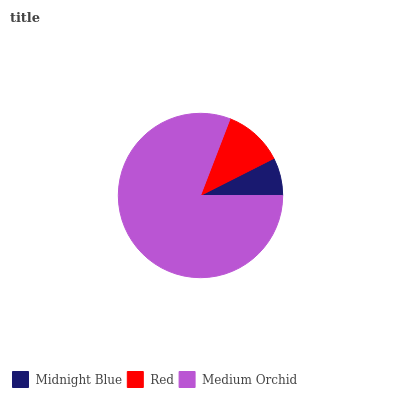Is Midnight Blue the minimum?
Answer yes or no. Yes. Is Medium Orchid the maximum?
Answer yes or no. Yes. Is Red the minimum?
Answer yes or no. No. Is Red the maximum?
Answer yes or no. No. Is Red greater than Midnight Blue?
Answer yes or no. Yes. Is Midnight Blue less than Red?
Answer yes or no. Yes. Is Midnight Blue greater than Red?
Answer yes or no. No. Is Red less than Midnight Blue?
Answer yes or no. No. Is Red the high median?
Answer yes or no. Yes. Is Red the low median?
Answer yes or no. Yes. Is Midnight Blue the high median?
Answer yes or no. No. Is Medium Orchid the low median?
Answer yes or no. No. 